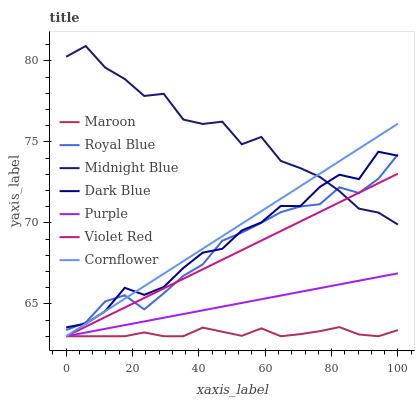Does Maroon have the minimum area under the curve?
Answer yes or no. Yes. Does Midnight Blue have the maximum area under the curve?
Answer yes or no. Yes. Does Violet Red have the minimum area under the curve?
Answer yes or no. No. Does Violet Red have the maximum area under the curve?
Answer yes or no. No. Is Violet Red the smoothest?
Answer yes or no. Yes. Is Midnight Blue the roughest?
Answer yes or no. Yes. Is Midnight Blue the smoothest?
Answer yes or no. No. Is Violet Red the roughest?
Answer yes or no. No. Does Cornflower have the lowest value?
Answer yes or no. Yes. Does Midnight Blue have the lowest value?
Answer yes or no. No. Does Midnight Blue have the highest value?
Answer yes or no. Yes. Does Violet Red have the highest value?
Answer yes or no. No. Is Maroon less than Royal Blue?
Answer yes or no. Yes. Is Dark Blue greater than Purple?
Answer yes or no. Yes. Does Violet Red intersect Midnight Blue?
Answer yes or no. Yes. Is Violet Red less than Midnight Blue?
Answer yes or no. No. Is Violet Red greater than Midnight Blue?
Answer yes or no. No. Does Maroon intersect Royal Blue?
Answer yes or no. No. 